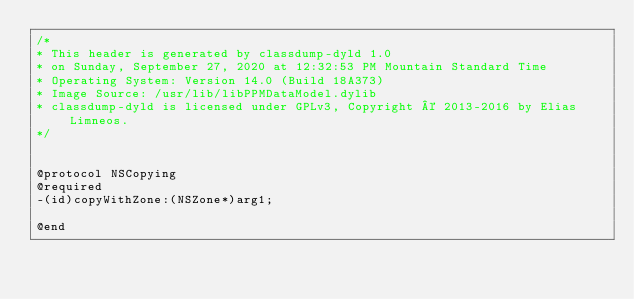Convert code to text. <code><loc_0><loc_0><loc_500><loc_500><_C_>/*
* This header is generated by classdump-dyld 1.0
* on Sunday, September 27, 2020 at 12:32:53 PM Mountain Standard Time
* Operating System: Version 14.0 (Build 18A373)
* Image Source: /usr/lib/libPPMDataModel.dylib
* classdump-dyld is licensed under GPLv3, Copyright © 2013-2016 by Elias Limneos.
*/


@protocol NSCopying
@required
-(id)copyWithZone:(NSZone*)arg1;

@end

</code> 